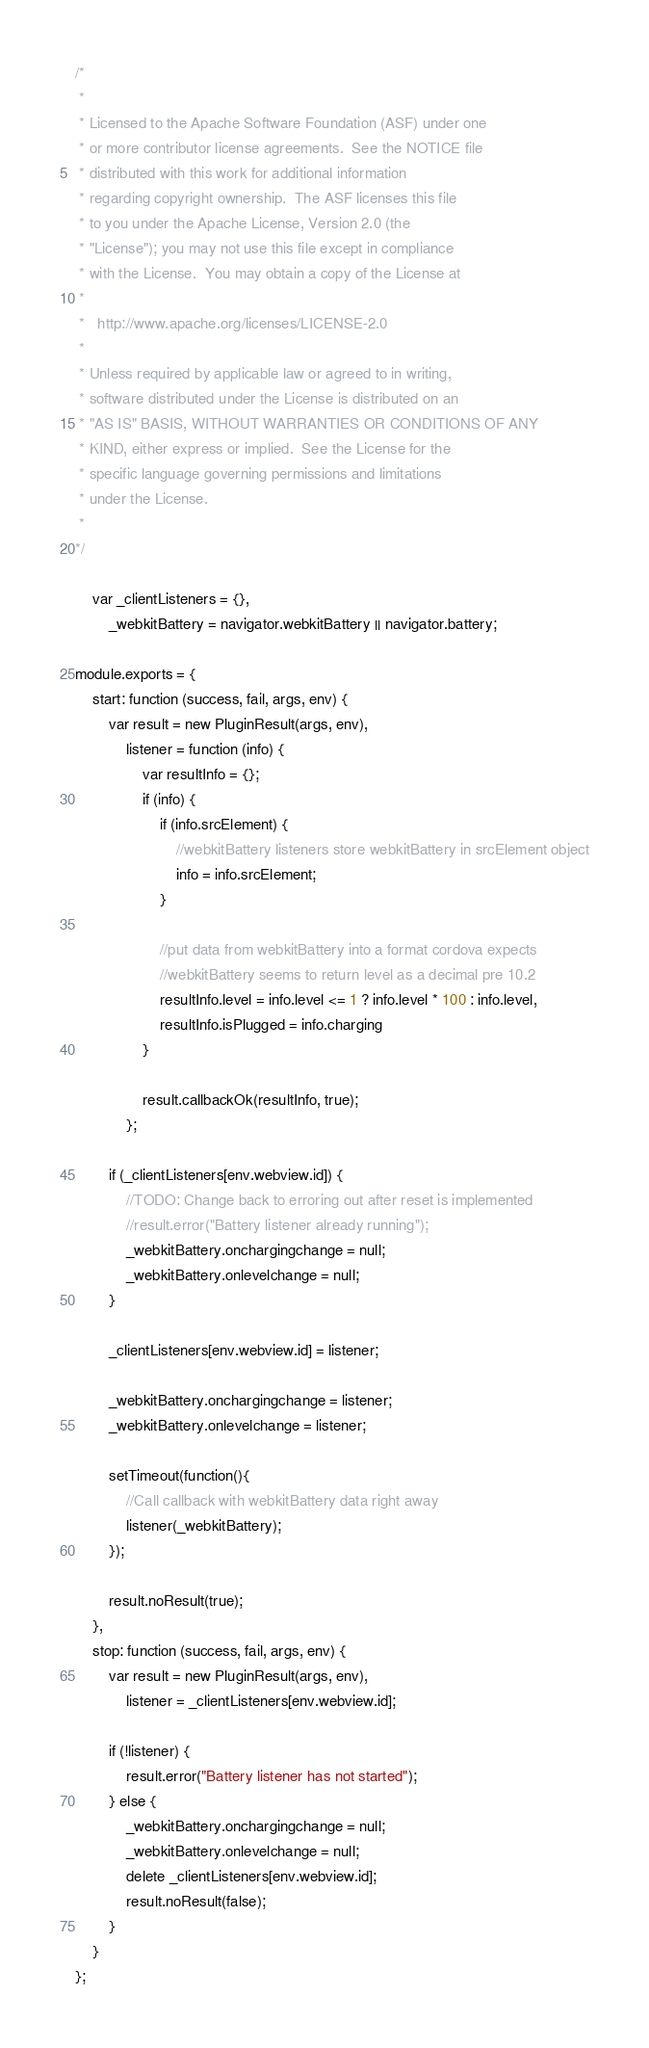Convert code to text. <code><loc_0><loc_0><loc_500><loc_500><_JavaScript_>/*
 *
 * Licensed to the Apache Software Foundation (ASF) under one
 * or more contributor license agreements.  See the NOTICE file
 * distributed with this work for additional information
 * regarding copyright ownership.  The ASF licenses this file
 * to you under the Apache License, Version 2.0 (the
 * "License"); you may not use this file except in compliance
 * with the License.  You may obtain a copy of the License at
 *
 *   http://www.apache.org/licenses/LICENSE-2.0
 *
 * Unless required by applicable law or agreed to in writing,
 * software distributed under the License is distributed on an
 * "AS IS" BASIS, WITHOUT WARRANTIES OR CONDITIONS OF ANY
 * KIND, either express or implied.  See the License for the
 * specific language governing permissions and limitations
 * under the License.
 *
*/

    var _clientListeners = {},
        _webkitBattery = navigator.webkitBattery || navigator.battery;

module.exports = {
    start: function (success, fail, args, env) {
        var result = new PluginResult(args, env),
            listener = function (info) {
                var resultInfo = {};
                if (info) {
                    if (info.srcElement) {
                        //webkitBattery listeners store webkitBattery in srcElement object
                        info = info.srcElement;
                    }

                    //put data from webkitBattery into a format cordova expects
                    //webkitBattery seems to return level as a decimal pre 10.2
                    resultInfo.level = info.level <= 1 ? info.level * 100 : info.level,
                    resultInfo.isPlugged = info.charging
                }

                result.callbackOk(resultInfo, true);
            };

        if (_clientListeners[env.webview.id]) {
            //TODO: Change back to erroring out after reset is implemented
            //result.error("Battery listener already running");
            _webkitBattery.onchargingchange = null;
            _webkitBattery.onlevelchange = null;
        }

        _clientListeners[env.webview.id] = listener;

        _webkitBattery.onchargingchange = listener;
        _webkitBattery.onlevelchange = listener;

        setTimeout(function(){
            //Call callback with webkitBattery data right away
            listener(_webkitBattery);
        });

        result.noResult(true);
    },
    stop: function (success, fail, args, env) {
        var result = new PluginResult(args, env),
            listener = _clientListeners[env.webview.id];

        if (!listener) {
            result.error("Battery listener has not started");
        } else {
            _webkitBattery.onchargingchange = null;
            _webkitBattery.onlevelchange = null;
            delete _clientListeners[env.webview.id];
            result.noResult(false);
        }
    }
};
</code> 